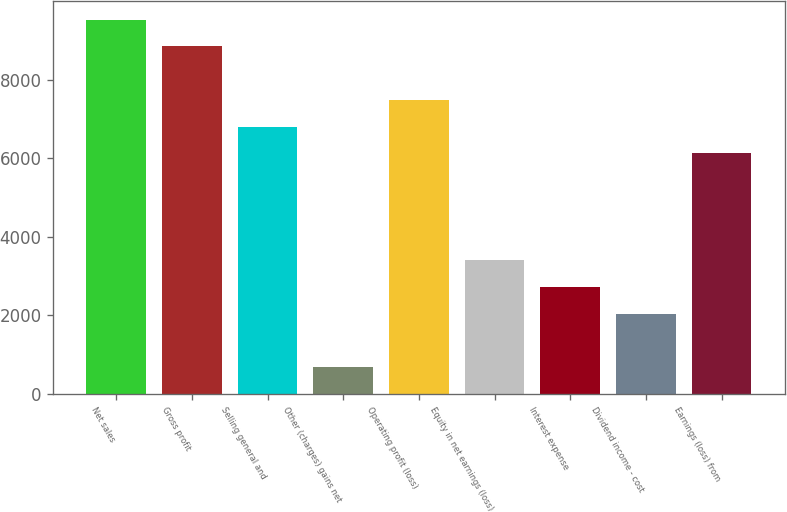Convert chart. <chart><loc_0><loc_0><loc_500><loc_500><bar_chart><fcel>Net sales<fcel>Gross profit<fcel>Selling general and<fcel>Other (charges) gains net<fcel>Operating profit (loss)<fcel>Equity in net earnings (loss)<fcel>Interest expense<fcel>Dividend income - cost<fcel>Earnings (loss) from<nl><fcel>9520<fcel>8840.5<fcel>6802<fcel>686.5<fcel>7481.5<fcel>3404.5<fcel>2725<fcel>2045.5<fcel>6122.5<nl></chart> 